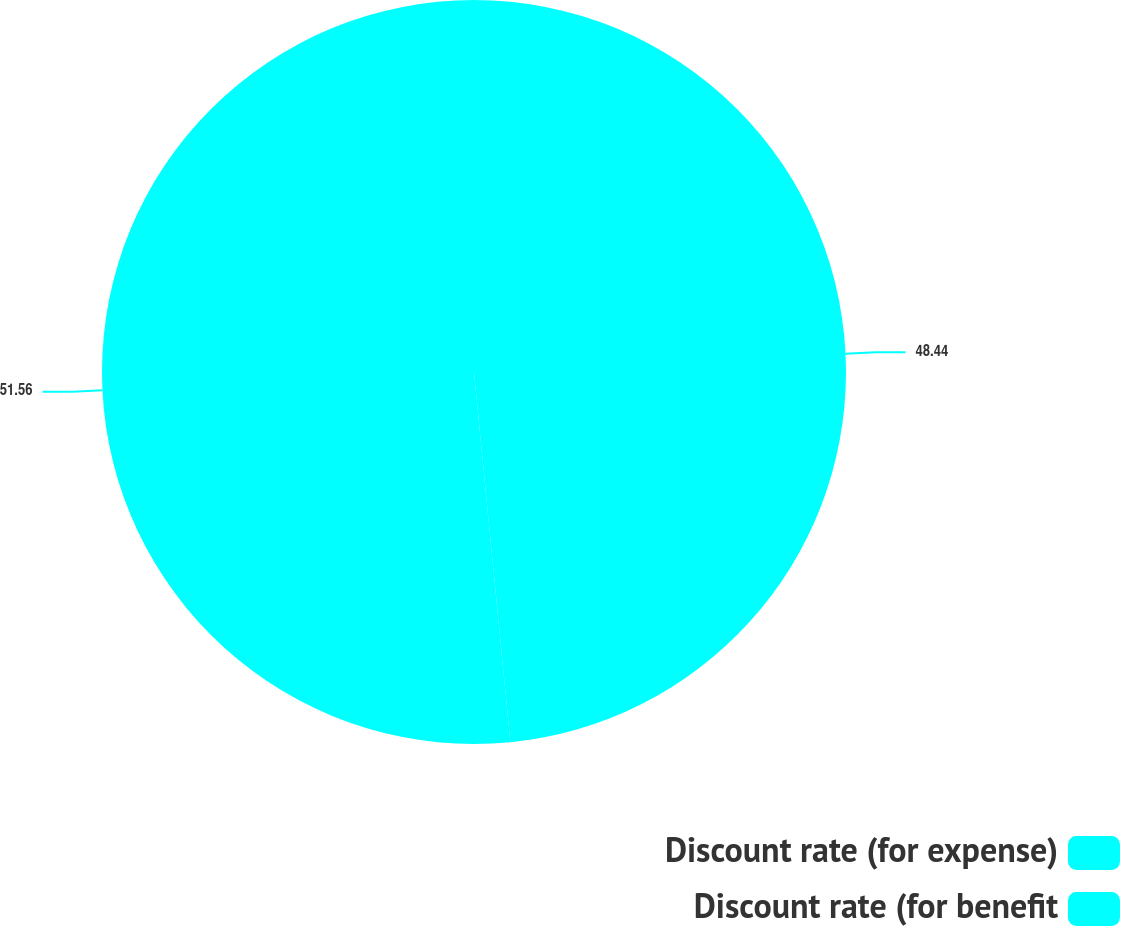Convert chart to OTSL. <chart><loc_0><loc_0><loc_500><loc_500><pie_chart><fcel>Discount rate (for expense)<fcel>Discount rate (for benefit<nl><fcel>48.44%<fcel>51.56%<nl></chart> 